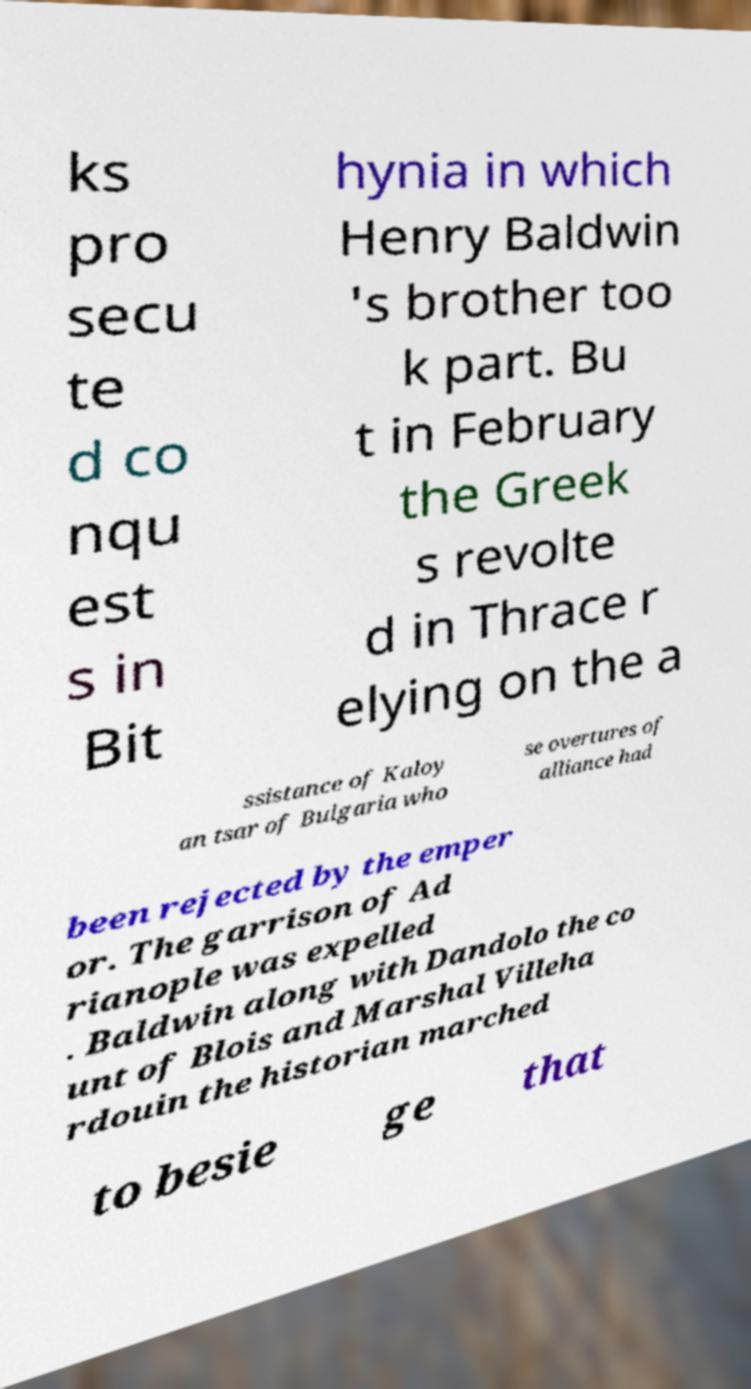Can you read and provide the text displayed in the image?This photo seems to have some interesting text. Can you extract and type it out for me? ks pro secu te d co nqu est s in Bit hynia in which Henry Baldwin 's brother too k part. Bu t in February the Greek s revolte d in Thrace r elying on the a ssistance of Kaloy an tsar of Bulgaria who se overtures of alliance had been rejected by the emper or. The garrison of Ad rianople was expelled . Baldwin along with Dandolo the co unt of Blois and Marshal Villeha rdouin the historian marched to besie ge that 